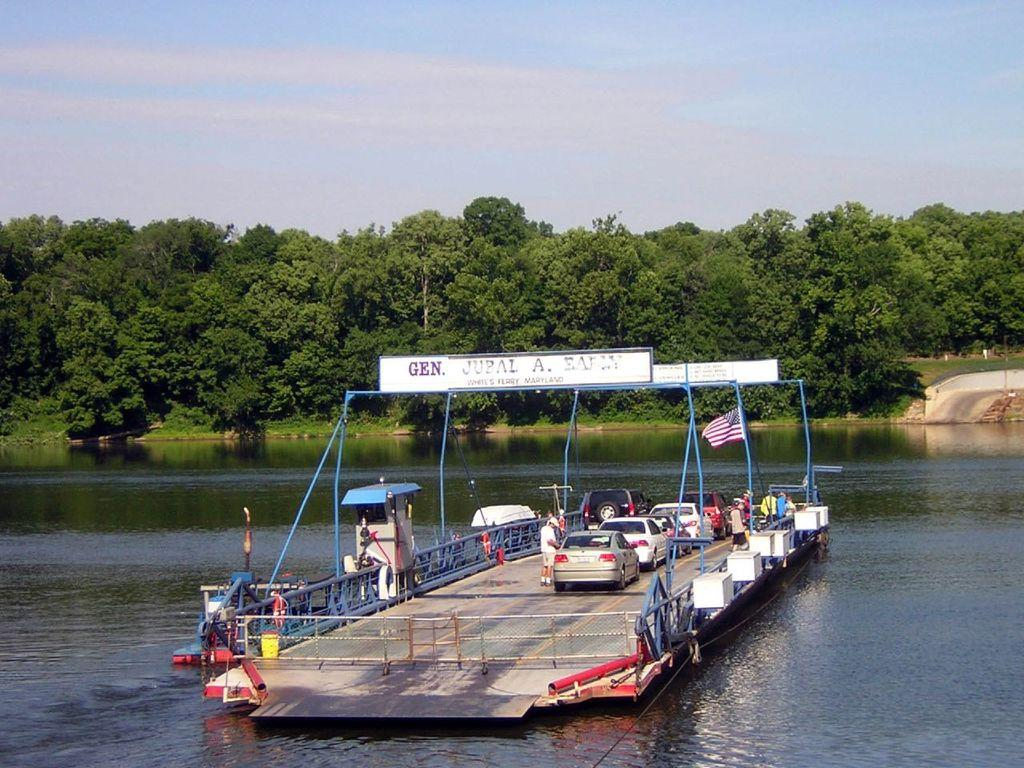What is located in the water in the image? There is a boat in the water. What type of vehicles are on the ground in the image? There are cars on the ground. What is attached to the pole in the image? There is a flag associated with the pole. What type of vegetation can be seen in the image? There are trees in the image. What part of the natural environment is visible in the image? The sky is visible in the image. What type of mouth can be seen on the boat in the image? There is no mouth present on the boat in the image. What thrill can be experienced by the cars in the image? The cars in the image are stationary, so there is no thrill being experienced. 